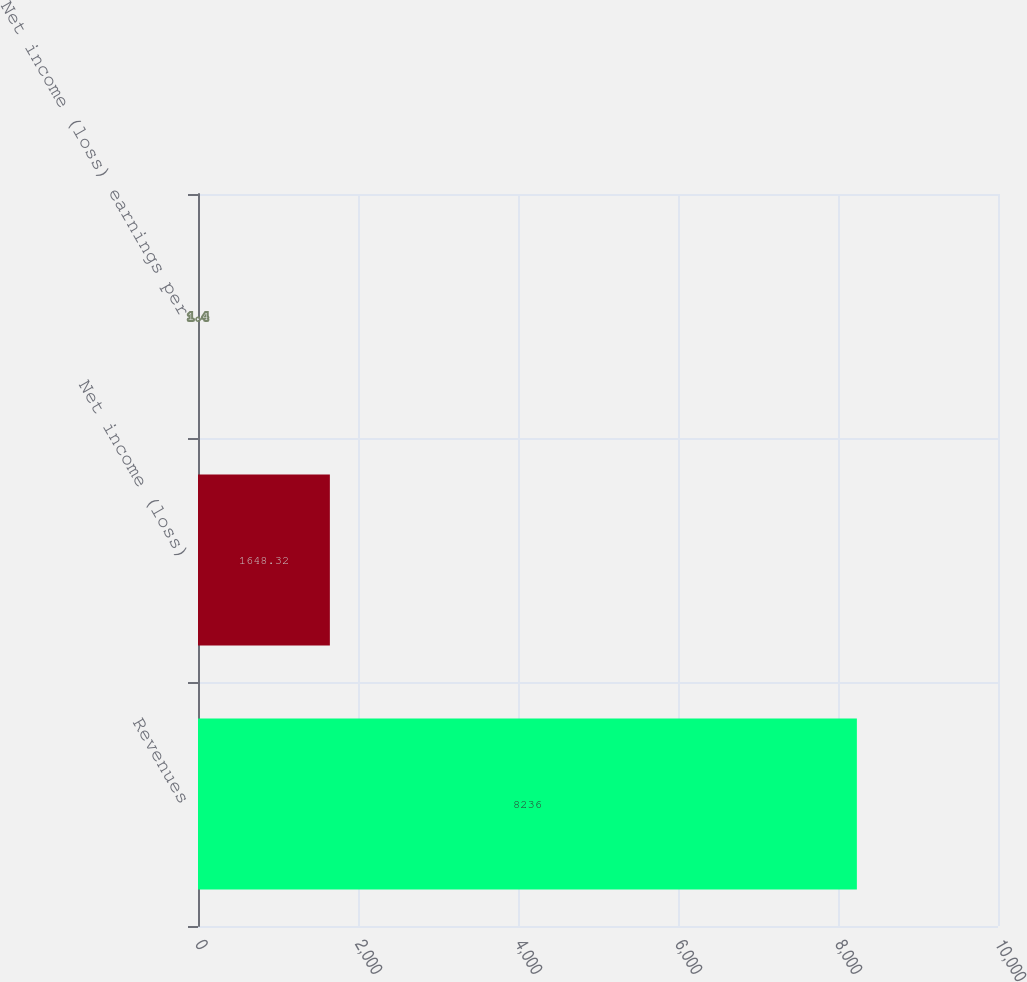<chart> <loc_0><loc_0><loc_500><loc_500><bar_chart><fcel>Revenues<fcel>Net income (loss)<fcel>Net income (loss) earnings per<nl><fcel>8236<fcel>1648.32<fcel>1.4<nl></chart> 